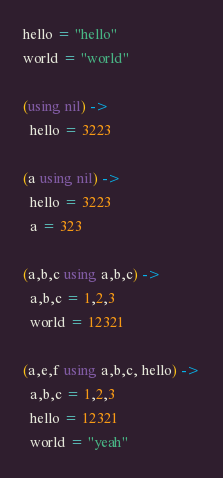Convert code to text. <code><loc_0><loc_0><loc_500><loc_500><_MoonScript_>
hello = "hello"
world = "world"

(using nil) ->
  hello = 3223

(a using nil) ->
  hello = 3223
  a = 323

(a,b,c using a,b,c) ->
  a,b,c = 1,2,3
  world = 12321

(a,e,f using a,b,c, hello) ->
  a,b,c = 1,2,3
  hello = 12321
  world = "yeah"


</code> 